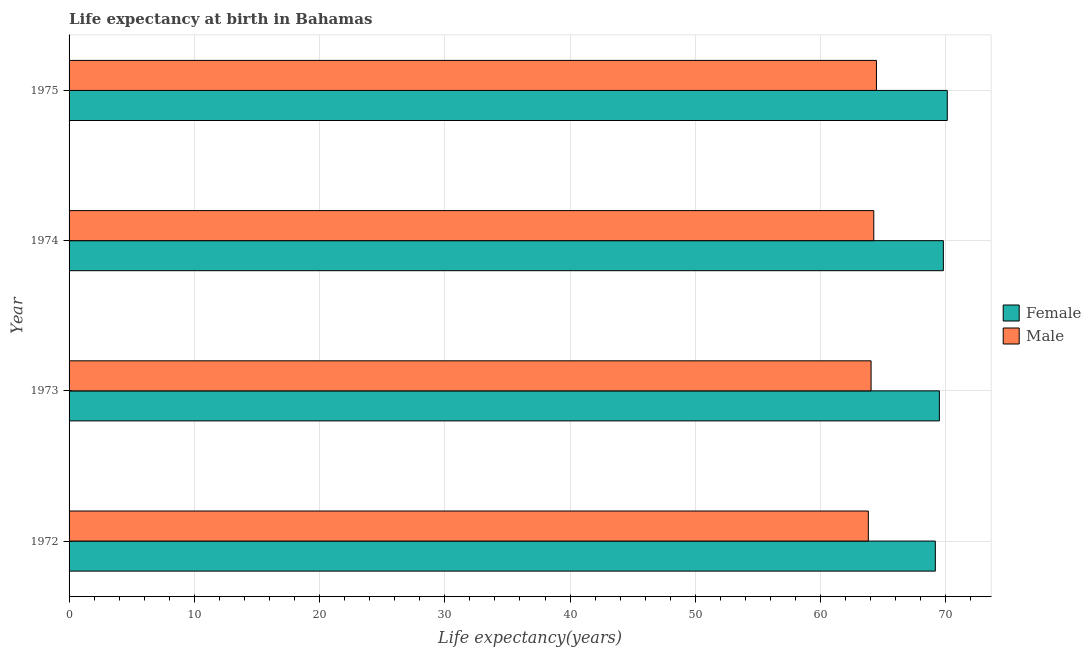How many different coloured bars are there?
Your response must be concise. 2. Are the number of bars on each tick of the Y-axis equal?
Your answer should be compact. Yes. How many bars are there on the 2nd tick from the bottom?
Offer a terse response. 2. What is the label of the 1st group of bars from the top?
Offer a very short reply. 1975. In how many cases, is the number of bars for a given year not equal to the number of legend labels?
Offer a terse response. 0. What is the life expectancy(male) in 1975?
Give a very brief answer. 64.46. Across all years, what is the maximum life expectancy(male)?
Offer a terse response. 64.46. Across all years, what is the minimum life expectancy(male)?
Keep it short and to the point. 63.81. In which year was the life expectancy(male) maximum?
Your answer should be very brief. 1975. What is the total life expectancy(male) in the graph?
Provide a short and direct response. 256.56. What is the difference between the life expectancy(male) in 1973 and that in 1974?
Your answer should be compact. -0.22. What is the difference between the life expectancy(female) in 1975 and the life expectancy(male) in 1974?
Keep it short and to the point. 5.87. What is the average life expectancy(male) per year?
Give a very brief answer. 64.14. In the year 1975, what is the difference between the life expectancy(male) and life expectancy(female)?
Keep it short and to the point. -5.66. In how many years, is the life expectancy(female) greater than 62 years?
Make the answer very short. 4. What is the ratio of the life expectancy(male) in 1972 to that in 1974?
Your response must be concise. 0.99. Is the life expectancy(female) in 1974 less than that in 1975?
Offer a terse response. Yes. What is the difference between the highest and the second highest life expectancy(male)?
Provide a short and direct response. 0.21. What is the difference between the highest and the lowest life expectancy(female)?
Your answer should be very brief. 0.96. In how many years, is the life expectancy(male) greater than the average life expectancy(male) taken over all years?
Your answer should be compact. 2. Is the sum of the life expectancy(male) in 1972 and 1973 greater than the maximum life expectancy(female) across all years?
Your response must be concise. Yes. What does the 2nd bar from the top in 1973 represents?
Give a very brief answer. Female. What does the 2nd bar from the bottom in 1974 represents?
Provide a succinct answer. Male. How many bars are there?
Your answer should be very brief. 8. How many years are there in the graph?
Your answer should be very brief. 4. Does the graph contain grids?
Offer a very short reply. Yes. How many legend labels are there?
Your answer should be compact. 2. How are the legend labels stacked?
Ensure brevity in your answer.  Vertical. What is the title of the graph?
Your answer should be compact. Life expectancy at birth in Bahamas. What is the label or title of the X-axis?
Your answer should be compact. Life expectancy(years). What is the Life expectancy(years) in Female in 1972?
Provide a succinct answer. 69.16. What is the Life expectancy(years) in Male in 1972?
Provide a succinct answer. 63.81. What is the Life expectancy(years) in Female in 1973?
Provide a short and direct response. 69.49. What is the Life expectancy(years) in Male in 1973?
Your response must be concise. 64.03. What is the Life expectancy(years) in Female in 1974?
Offer a terse response. 69.8. What is the Life expectancy(years) in Male in 1974?
Offer a terse response. 64.25. What is the Life expectancy(years) in Female in 1975?
Your response must be concise. 70.12. What is the Life expectancy(years) in Male in 1975?
Your response must be concise. 64.46. Across all years, what is the maximum Life expectancy(years) of Female?
Offer a very short reply. 70.12. Across all years, what is the maximum Life expectancy(years) in Male?
Offer a terse response. 64.46. Across all years, what is the minimum Life expectancy(years) of Female?
Make the answer very short. 69.16. Across all years, what is the minimum Life expectancy(years) in Male?
Offer a terse response. 63.81. What is the total Life expectancy(years) of Female in the graph?
Your response must be concise. 278.57. What is the total Life expectancy(years) of Male in the graph?
Your response must be concise. 256.56. What is the difference between the Life expectancy(years) in Female in 1972 and that in 1973?
Your answer should be compact. -0.32. What is the difference between the Life expectancy(years) of Male in 1972 and that in 1973?
Offer a very short reply. -0.22. What is the difference between the Life expectancy(years) of Female in 1972 and that in 1974?
Your answer should be very brief. -0.64. What is the difference between the Life expectancy(years) in Male in 1972 and that in 1974?
Make the answer very short. -0.44. What is the difference between the Life expectancy(years) in Female in 1972 and that in 1975?
Offer a terse response. -0.95. What is the difference between the Life expectancy(years) of Male in 1972 and that in 1975?
Offer a very short reply. -0.65. What is the difference between the Life expectancy(years) of Female in 1973 and that in 1974?
Provide a short and direct response. -0.32. What is the difference between the Life expectancy(years) of Male in 1973 and that in 1974?
Provide a succinct answer. -0.22. What is the difference between the Life expectancy(years) of Female in 1973 and that in 1975?
Your answer should be very brief. -0.63. What is the difference between the Life expectancy(years) in Male in 1973 and that in 1975?
Provide a succinct answer. -0.43. What is the difference between the Life expectancy(years) of Female in 1974 and that in 1975?
Offer a very short reply. -0.31. What is the difference between the Life expectancy(years) in Male in 1974 and that in 1975?
Your response must be concise. -0.21. What is the difference between the Life expectancy(years) of Female in 1972 and the Life expectancy(years) of Male in 1973?
Your response must be concise. 5.13. What is the difference between the Life expectancy(years) in Female in 1972 and the Life expectancy(years) in Male in 1974?
Keep it short and to the point. 4.91. What is the difference between the Life expectancy(years) in Female in 1972 and the Life expectancy(years) in Male in 1975?
Ensure brevity in your answer.  4.7. What is the difference between the Life expectancy(years) in Female in 1973 and the Life expectancy(years) in Male in 1974?
Your response must be concise. 5.24. What is the difference between the Life expectancy(years) of Female in 1973 and the Life expectancy(years) of Male in 1975?
Give a very brief answer. 5.03. What is the difference between the Life expectancy(years) of Female in 1974 and the Life expectancy(years) of Male in 1975?
Keep it short and to the point. 5.34. What is the average Life expectancy(years) of Female per year?
Your answer should be compact. 69.64. What is the average Life expectancy(years) in Male per year?
Give a very brief answer. 64.14. In the year 1972, what is the difference between the Life expectancy(years) in Female and Life expectancy(years) in Male?
Give a very brief answer. 5.35. In the year 1973, what is the difference between the Life expectancy(years) in Female and Life expectancy(years) in Male?
Ensure brevity in your answer.  5.45. In the year 1974, what is the difference between the Life expectancy(years) of Female and Life expectancy(years) of Male?
Your response must be concise. 5.55. In the year 1975, what is the difference between the Life expectancy(years) of Female and Life expectancy(years) of Male?
Offer a very short reply. 5.66. What is the ratio of the Life expectancy(years) of Female in 1972 to that in 1973?
Ensure brevity in your answer.  1. What is the ratio of the Life expectancy(years) in Female in 1972 to that in 1974?
Ensure brevity in your answer.  0.99. What is the ratio of the Life expectancy(years) in Female in 1972 to that in 1975?
Give a very brief answer. 0.99. What is the ratio of the Life expectancy(years) of Male in 1972 to that in 1975?
Offer a terse response. 0.99. What is the ratio of the Life expectancy(years) of Female in 1973 to that in 1974?
Provide a short and direct response. 1. What is the ratio of the Life expectancy(years) in Male in 1973 to that in 1974?
Give a very brief answer. 1. What is the ratio of the Life expectancy(years) in Male in 1973 to that in 1975?
Offer a very short reply. 0.99. What is the ratio of the Life expectancy(years) of Female in 1974 to that in 1975?
Offer a very short reply. 1. What is the difference between the highest and the second highest Life expectancy(years) of Female?
Provide a succinct answer. 0.31. What is the difference between the highest and the second highest Life expectancy(years) in Male?
Keep it short and to the point. 0.21. What is the difference between the highest and the lowest Life expectancy(years) in Female?
Keep it short and to the point. 0.95. What is the difference between the highest and the lowest Life expectancy(years) in Male?
Give a very brief answer. 0.65. 